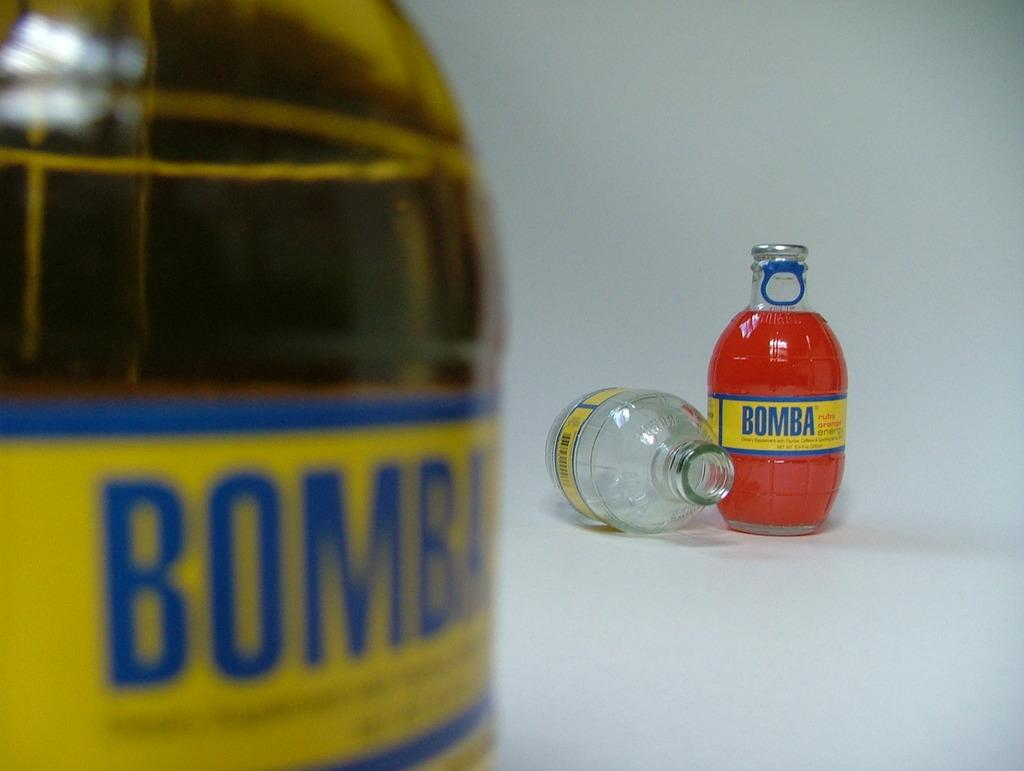<image>
Create a compact narrative representing the image presented. glass jars of Bomba ruby orange energy drink 